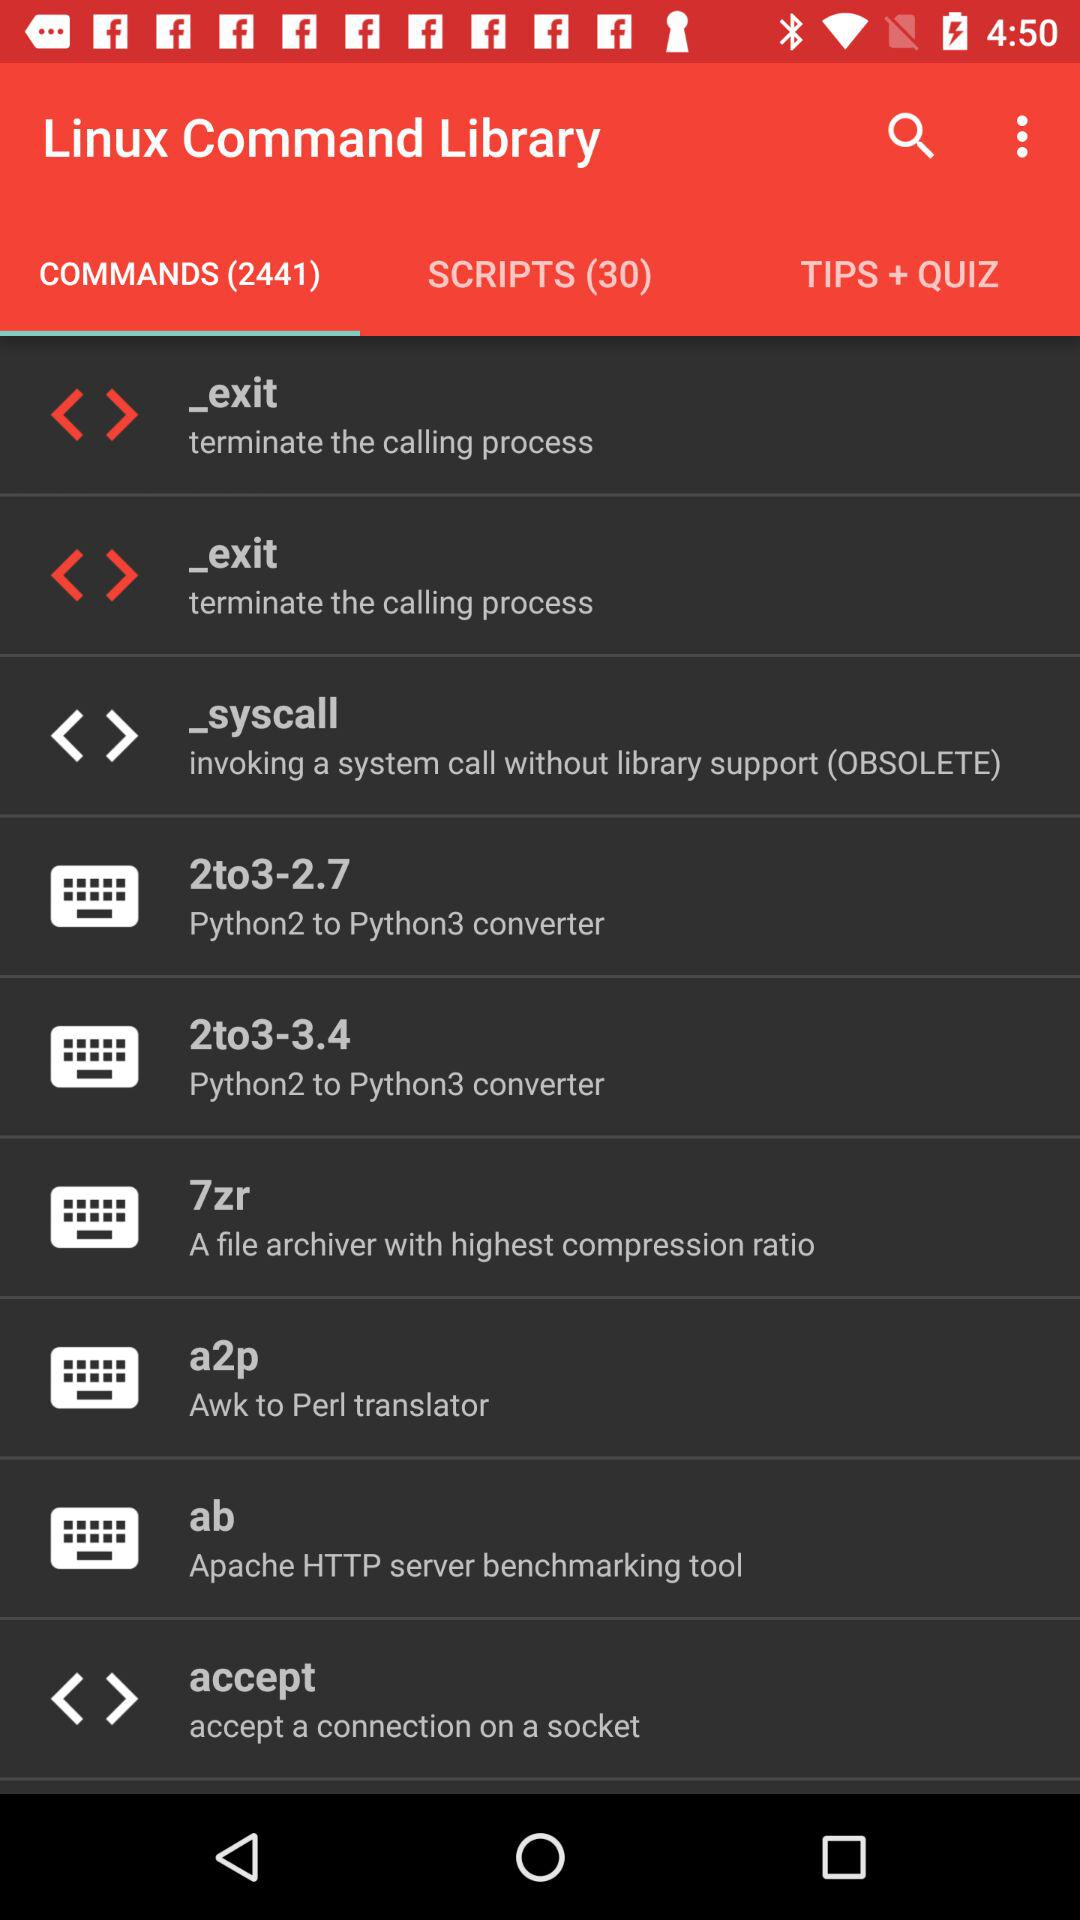What is the total number of commands? The total number of commands is 2441. 